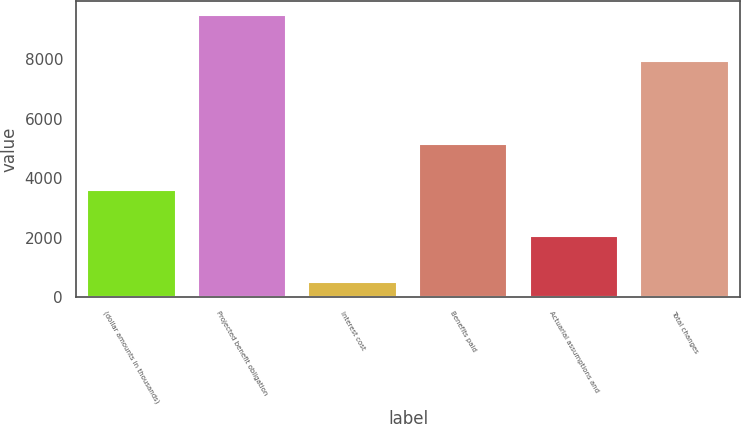Convert chart to OTSL. <chart><loc_0><loc_0><loc_500><loc_500><bar_chart><fcel>(dollar amounts in thousands)<fcel>Projected benefit obligation<fcel>Interest cost<fcel>Benefits paid<fcel>Actuarial assumptions and<fcel>Total changes<nl><fcel>3597.4<fcel>9483.7<fcel>506<fcel>5143.1<fcel>2051.7<fcel>7938<nl></chart> 